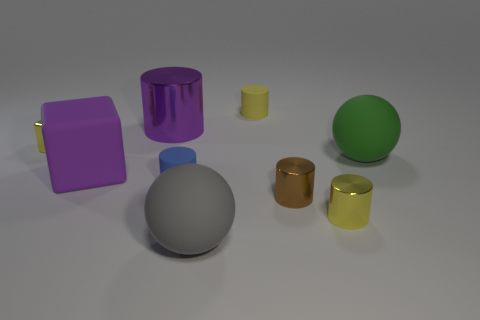Subtract all purple cylinders. How many cylinders are left? 4 Subtract 4 cylinders. How many cylinders are left? 1 Subtract all yellow cylinders. How many cylinders are left? 3 Subtract all cylinders. How many objects are left? 4 Subtract 1 gray spheres. How many objects are left? 8 Subtract all purple spheres. Subtract all green cylinders. How many spheres are left? 2 Subtract all purple spheres. How many cyan cylinders are left? 0 Subtract all large purple cylinders. Subtract all tiny blue cylinders. How many objects are left? 7 Add 4 big cylinders. How many big cylinders are left? 5 Add 5 tiny yellow cubes. How many tiny yellow cubes exist? 6 